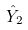Convert formula to latex. <formula><loc_0><loc_0><loc_500><loc_500>\hat { Y } _ { 2 }</formula> 